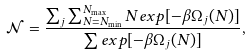<formula> <loc_0><loc_0><loc_500><loc_500>\mathcal { N } = \frac { \sum _ { j } \sum _ { N = N _ { \min } } ^ { N _ { \max } } N e x p [ - \beta \Omega _ { j } ( N ) ] } { \sum e x p [ - \beta \Omega _ { j } ( N ) ] } ,</formula> 